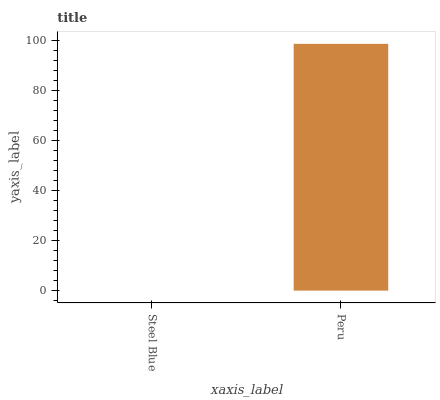Is Steel Blue the minimum?
Answer yes or no. Yes. Is Peru the maximum?
Answer yes or no. Yes. Is Peru the minimum?
Answer yes or no. No. Is Peru greater than Steel Blue?
Answer yes or no. Yes. Is Steel Blue less than Peru?
Answer yes or no. Yes. Is Steel Blue greater than Peru?
Answer yes or no. No. Is Peru less than Steel Blue?
Answer yes or no. No. Is Peru the high median?
Answer yes or no. Yes. Is Steel Blue the low median?
Answer yes or no. Yes. Is Steel Blue the high median?
Answer yes or no. No. Is Peru the low median?
Answer yes or no. No. 